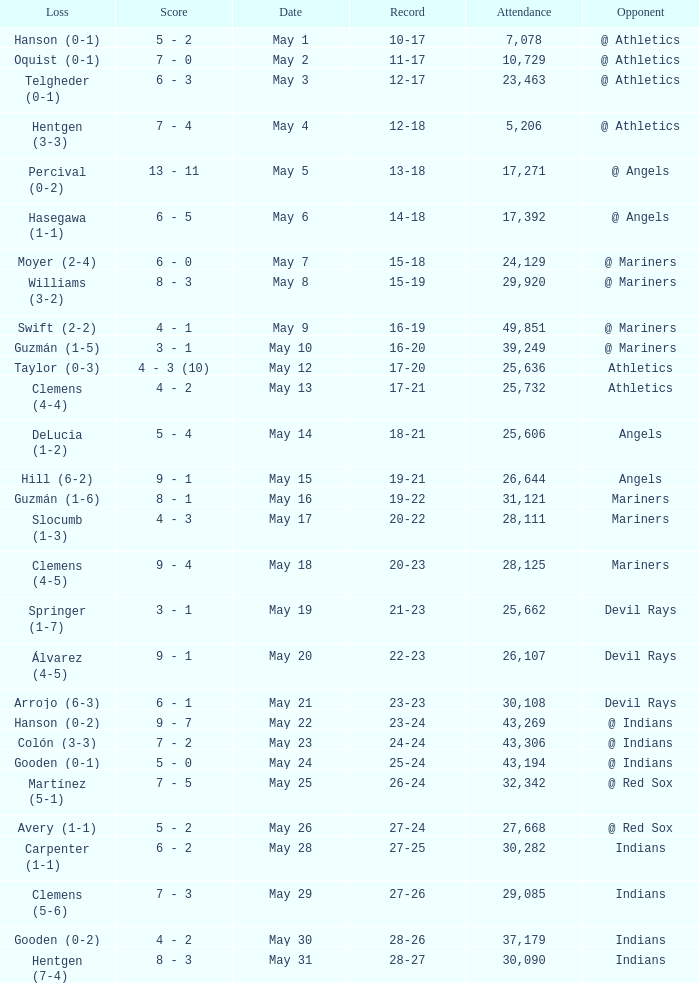When the record is 16-20 and attendance is greater than 32,342, what is the score? 3 - 1. 